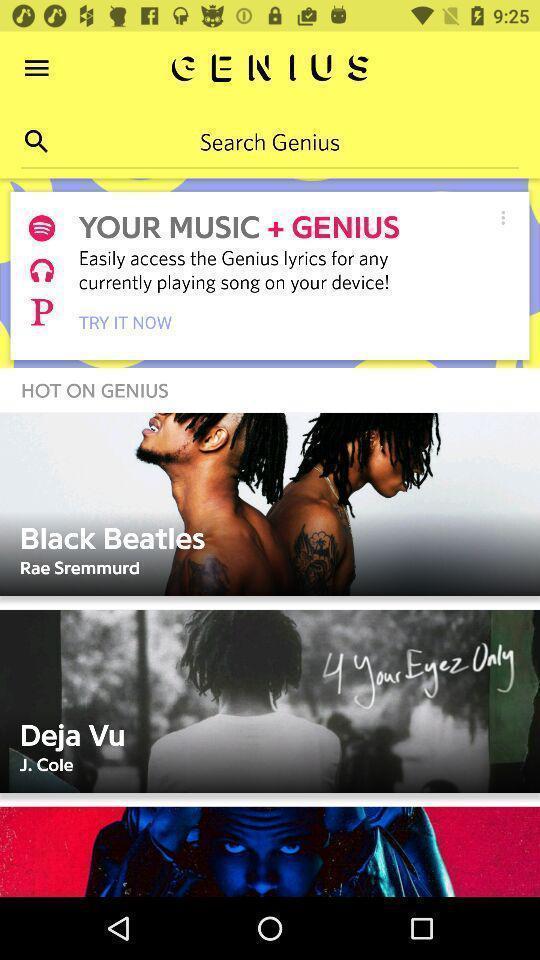Describe this image in words. Screen shows search option in a music app. 